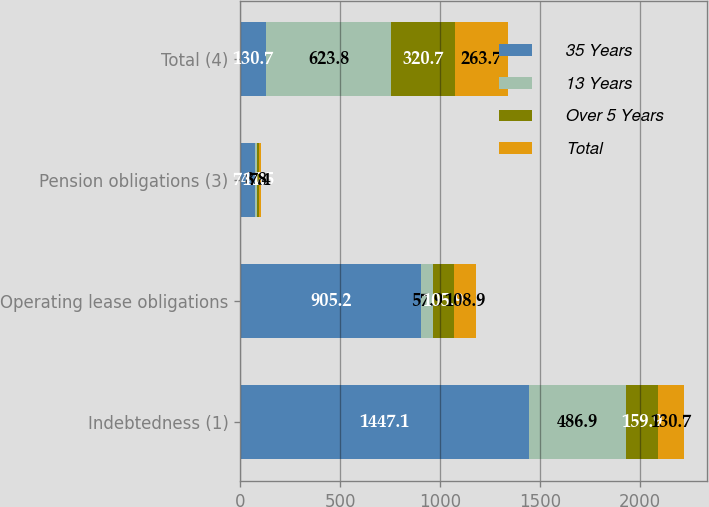Convert chart to OTSL. <chart><loc_0><loc_0><loc_500><loc_500><stacked_bar_chart><ecel><fcel>Indebtedness (1)<fcel>Operating lease obligations<fcel>Pension obligations (3)<fcel>Total (4)<nl><fcel>35 Years<fcel>1447.1<fcel>905.2<fcel>74.2<fcel>130.7<nl><fcel>13 Years<fcel>486.9<fcel>57.9<fcel>8.8<fcel>623.8<nl><fcel>Over 5 Years<fcel>159.9<fcel>105.9<fcel>11.5<fcel>320.7<nl><fcel>Total<fcel>130.7<fcel>108.9<fcel>7.4<fcel>263.7<nl></chart> 